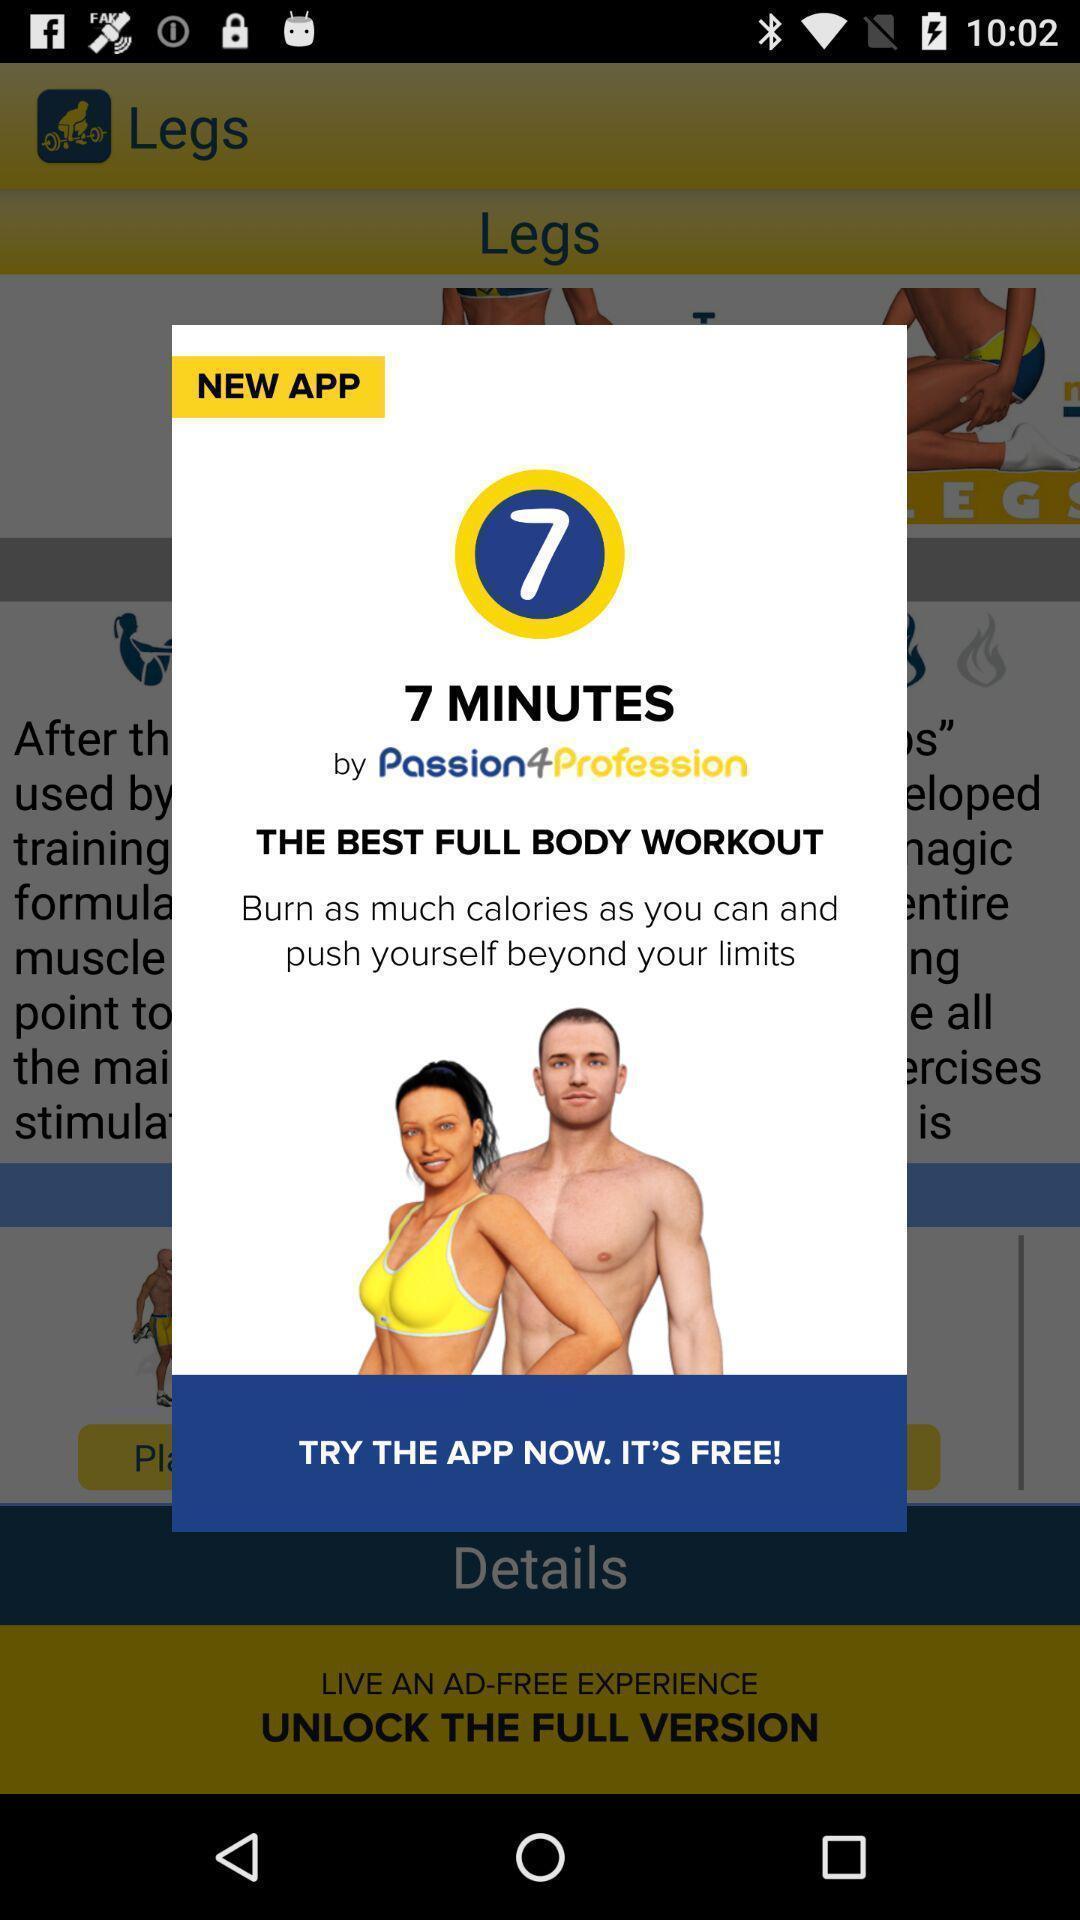What is the overall content of this screenshot? Pop-up page showing information about fitness app. 